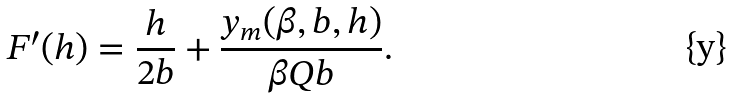<formula> <loc_0><loc_0><loc_500><loc_500>F ^ { \prime } ( h ) = \frac { h } { 2 b } + \frac { y _ { m } ( \beta , b , h ) } { \beta Q b } .</formula> 